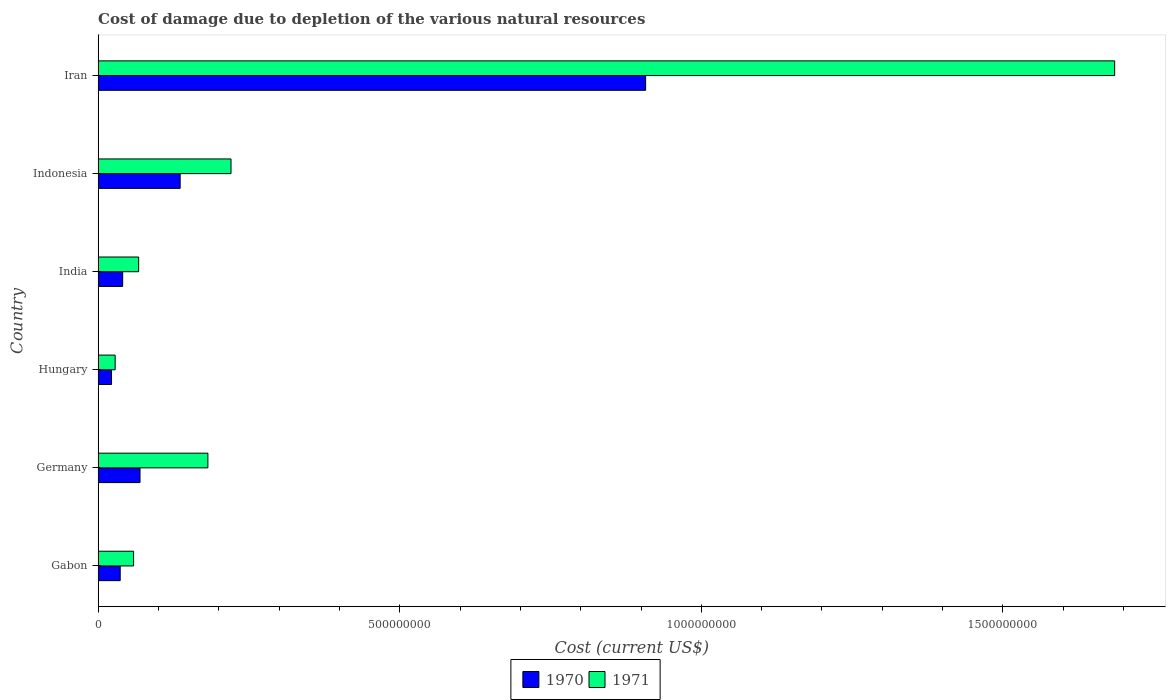Are the number of bars per tick equal to the number of legend labels?
Offer a terse response. Yes. Are the number of bars on each tick of the Y-axis equal?
Your response must be concise. Yes. How many bars are there on the 1st tick from the bottom?
Offer a very short reply. 2. In how many cases, is the number of bars for a given country not equal to the number of legend labels?
Your answer should be very brief. 0. What is the cost of damage caused due to the depletion of various natural resources in 1970 in Germany?
Your answer should be compact. 6.95e+07. Across all countries, what is the maximum cost of damage caused due to the depletion of various natural resources in 1970?
Keep it short and to the point. 9.08e+08. Across all countries, what is the minimum cost of damage caused due to the depletion of various natural resources in 1970?
Your answer should be compact. 2.22e+07. In which country was the cost of damage caused due to the depletion of various natural resources in 1971 maximum?
Your answer should be compact. Iran. In which country was the cost of damage caused due to the depletion of various natural resources in 1970 minimum?
Your answer should be compact. Hungary. What is the total cost of damage caused due to the depletion of various natural resources in 1970 in the graph?
Your response must be concise. 1.21e+09. What is the difference between the cost of damage caused due to the depletion of various natural resources in 1971 in Gabon and that in Iran?
Make the answer very short. -1.63e+09. What is the difference between the cost of damage caused due to the depletion of various natural resources in 1970 in Iran and the cost of damage caused due to the depletion of various natural resources in 1971 in Hungary?
Give a very brief answer. 8.79e+08. What is the average cost of damage caused due to the depletion of various natural resources in 1970 per country?
Ensure brevity in your answer.  2.02e+08. What is the difference between the cost of damage caused due to the depletion of various natural resources in 1970 and cost of damage caused due to the depletion of various natural resources in 1971 in Iran?
Ensure brevity in your answer.  -7.78e+08. In how many countries, is the cost of damage caused due to the depletion of various natural resources in 1970 greater than 100000000 US$?
Your answer should be compact. 2. What is the ratio of the cost of damage caused due to the depletion of various natural resources in 1971 in Hungary to that in India?
Your response must be concise. 0.42. Is the difference between the cost of damage caused due to the depletion of various natural resources in 1970 in Gabon and Indonesia greater than the difference between the cost of damage caused due to the depletion of various natural resources in 1971 in Gabon and Indonesia?
Your answer should be compact. Yes. What is the difference between the highest and the second highest cost of damage caused due to the depletion of various natural resources in 1970?
Provide a succinct answer. 7.72e+08. What is the difference between the highest and the lowest cost of damage caused due to the depletion of various natural resources in 1971?
Offer a terse response. 1.66e+09. In how many countries, is the cost of damage caused due to the depletion of various natural resources in 1970 greater than the average cost of damage caused due to the depletion of various natural resources in 1970 taken over all countries?
Your answer should be very brief. 1. Is the sum of the cost of damage caused due to the depletion of various natural resources in 1970 in Germany and Hungary greater than the maximum cost of damage caused due to the depletion of various natural resources in 1971 across all countries?
Keep it short and to the point. No. How many countries are there in the graph?
Ensure brevity in your answer.  6. Does the graph contain any zero values?
Ensure brevity in your answer.  No. Where does the legend appear in the graph?
Give a very brief answer. Bottom center. How many legend labels are there?
Provide a succinct answer. 2. How are the legend labels stacked?
Offer a terse response. Horizontal. What is the title of the graph?
Make the answer very short. Cost of damage due to depletion of the various natural resources. Does "2001" appear as one of the legend labels in the graph?
Offer a very short reply. No. What is the label or title of the X-axis?
Offer a terse response. Cost (current US$). What is the Cost (current US$) in 1970 in Gabon?
Give a very brief answer. 3.66e+07. What is the Cost (current US$) in 1971 in Gabon?
Your answer should be very brief. 5.88e+07. What is the Cost (current US$) of 1970 in Germany?
Offer a terse response. 6.95e+07. What is the Cost (current US$) of 1971 in Germany?
Keep it short and to the point. 1.82e+08. What is the Cost (current US$) of 1970 in Hungary?
Offer a very short reply. 2.22e+07. What is the Cost (current US$) of 1971 in Hungary?
Keep it short and to the point. 2.83e+07. What is the Cost (current US$) in 1970 in India?
Offer a very short reply. 4.07e+07. What is the Cost (current US$) in 1971 in India?
Offer a terse response. 6.72e+07. What is the Cost (current US$) of 1970 in Indonesia?
Your answer should be very brief. 1.36e+08. What is the Cost (current US$) in 1971 in Indonesia?
Your answer should be compact. 2.20e+08. What is the Cost (current US$) of 1970 in Iran?
Give a very brief answer. 9.08e+08. What is the Cost (current US$) in 1971 in Iran?
Keep it short and to the point. 1.69e+09. Across all countries, what is the maximum Cost (current US$) in 1970?
Provide a succinct answer. 9.08e+08. Across all countries, what is the maximum Cost (current US$) in 1971?
Provide a short and direct response. 1.69e+09. Across all countries, what is the minimum Cost (current US$) in 1970?
Offer a terse response. 2.22e+07. Across all countries, what is the minimum Cost (current US$) in 1971?
Your answer should be very brief. 2.83e+07. What is the total Cost (current US$) of 1970 in the graph?
Your response must be concise. 1.21e+09. What is the total Cost (current US$) in 1971 in the graph?
Provide a succinct answer. 2.24e+09. What is the difference between the Cost (current US$) in 1970 in Gabon and that in Germany?
Make the answer very short. -3.29e+07. What is the difference between the Cost (current US$) in 1971 in Gabon and that in Germany?
Your answer should be compact. -1.23e+08. What is the difference between the Cost (current US$) in 1970 in Gabon and that in Hungary?
Offer a very short reply. 1.44e+07. What is the difference between the Cost (current US$) in 1971 in Gabon and that in Hungary?
Offer a very short reply. 3.05e+07. What is the difference between the Cost (current US$) in 1970 in Gabon and that in India?
Offer a terse response. -4.09e+06. What is the difference between the Cost (current US$) in 1971 in Gabon and that in India?
Ensure brevity in your answer.  -8.41e+06. What is the difference between the Cost (current US$) in 1970 in Gabon and that in Indonesia?
Your answer should be very brief. -9.94e+07. What is the difference between the Cost (current US$) in 1971 in Gabon and that in Indonesia?
Your answer should be compact. -1.62e+08. What is the difference between the Cost (current US$) of 1970 in Gabon and that in Iran?
Offer a terse response. -8.71e+08. What is the difference between the Cost (current US$) of 1971 in Gabon and that in Iran?
Give a very brief answer. -1.63e+09. What is the difference between the Cost (current US$) of 1970 in Germany and that in Hungary?
Provide a succinct answer. 4.72e+07. What is the difference between the Cost (current US$) of 1971 in Germany and that in Hungary?
Provide a succinct answer. 1.54e+08. What is the difference between the Cost (current US$) of 1970 in Germany and that in India?
Ensure brevity in your answer.  2.88e+07. What is the difference between the Cost (current US$) of 1971 in Germany and that in India?
Offer a terse response. 1.15e+08. What is the difference between the Cost (current US$) of 1970 in Germany and that in Indonesia?
Ensure brevity in your answer.  -6.65e+07. What is the difference between the Cost (current US$) of 1971 in Germany and that in Indonesia?
Your answer should be compact. -3.83e+07. What is the difference between the Cost (current US$) in 1970 in Germany and that in Iran?
Your answer should be compact. -8.38e+08. What is the difference between the Cost (current US$) of 1971 in Germany and that in Iran?
Make the answer very short. -1.50e+09. What is the difference between the Cost (current US$) of 1970 in Hungary and that in India?
Your response must be concise. -1.85e+07. What is the difference between the Cost (current US$) in 1971 in Hungary and that in India?
Ensure brevity in your answer.  -3.89e+07. What is the difference between the Cost (current US$) of 1970 in Hungary and that in Indonesia?
Your answer should be compact. -1.14e+08. What is the difference between the Cost (current US$) in 1971 in Hungary and that in Indonesia?
Your response must be concise. -1.92e+08. What is the difference between the Cost (current US$) in 1970 in Hungary and that in Iran?
Keep it short and to the point. -8.85e+08. What is the difference between the Cost (current US$) in 1971 in Hungary and that in Iran?
Your answer should be very brief. -1.66e+09. What is the difference between the Cost (current US$) in 1970 in India and that in Indonesia?
Your answer should be compact. -9.53e+07. What is the difference between the Cost (current US$) in 1971 in India and that in Indonesia?
Make the answer very short. -1.53e+08. What is the difference between the Cost (current US$) in 1970 in India and that in Iran?
Make the answer very short. -8.67e+08. What is the difference between the Cost (current US$) of 1971 in India and that in Iran?
Your answer should be compact. -1.62e+09. What is the difference between the Cost (current US$) of 1970 in Indonesia and that in Iran?
Your response must be concise. -7.72e+08. What is the difference between the Cost (current US$) of 1971 in Indonesia and that in Iran?
Your response must be concise. -1.46e+09. What is the difference between the Cost (current US$) in 1970 in Gabon and the Cost (current US$) in 1971 in Germany?
Provide a short and direct response. -1.45e+08. What is the difference between the Cost (current US$) in 1970 in Gabon and the Cost (current US$) in 1971 in Hungary?
Your response must be concise. 8.35e+06. What is the difference between the Cost (current US$) in 1970 in Gabon and the Cost (current US$) in 1971 in India?
Give a very brief answer. -3.06e+07. What is the difference between the Cost (current US$) of 1970 in Gabon and the Cost (current US$) of 1971 in Indonesia?
Make the answer very short. -1.84e+08. What is the difference between the Cost (current US$) of 1970 in Gabon and the Cost (current US$) of 1971 in Iran?
Make the answer very short. -1.65e+09. What is the difference between the Cost (current US$) of 1970 in Germany and the Cost (current US$) of 1971 in Hungary?
Provide a short and direct response. 4.12e+07. What is the difference between the Cost (current US$) of 1970 in Germany and the Cost (current US$) of 1971 in India?
Give a very brief answer. 2.27e+06. What is the difference between the Cost (current US$) of 1970 in Germany and the Cost (current US$) of 1971 in Indonesia?
Provide a succinct answer. -1.51e+08. What is the difference between the Cost (current US$) in 1970 in Germany and the Cost (current US$) in 1971 in Iran?
Ensure brevity in your answer.  -1.62e+09. What is the difference between the Cost (current US$) of 1970 in Hungary and the Cost (current US$) of 1971 in India?
Provide a short and direct response. -4.50e+07. What is the difference between the Cost (current US$) in 1970 in Hungary and the Cost (current US$) in 1971 in Indonesia?
Offer a terse response. -1.98e+08. What is the difference between the Cost (current US$) in 1970 in Hungary and the Cost (current US$) in 1971 in Iran?
Keep it short and to the point. -1.66e+09. What is the difference between the Cost (current US$) in 1970 in India and the Cost (current US$) in 1971 in Indonesia?
Make the answer very short. -1.80e+08. What is the difference between the Cost (current US$) in 1970 in India and the Cost (current US$) in 1971 in Iran?
Your answer should be compact. -1.64e+09. What is the difference between the Cost (current US$) of 1970 in Indonesia and the Cost (current US$) of 1971 in Iran?
Your answer should be compact. -1.55e+09. What is the average Cost (current US$) in 1970 per country?
Offer a terse response. 2.02e+08. What is the average Cost (current US$) in 1971 per country?
Your answer should be very brief. 3.74e+08. What is the difference between the Cost (current US$) in 1970 and Cost (current US$) in 1971 in Gabon?
Ensure brevity in your answer.  -2.22e+07. What is the difference between the Cost (current US$) in 1970 and Cost (current US$) in 1971 in Germany?
Give a very brief answer. -1.13e+08. What is the difference between the Cost (current US$) of 1970 and Cost (current US$) of 1971 in Hungary?
Provide a short and direct response. -6.02e+06. What is the difference between the Cost (current US$) of 1970 and Cost (current US$) of 1971 in India?
Make the answer very short. -2.65e+07. What is the difference between the Cost (current US$) in 1970 and Cost (current US$) in 1971 in Indonesia?
Provide a succinct answer. -8.43e+07. What is the difference between the Cost (current US$) in 1970 and Cost (current US$) in 1971 in Iran?
Offer a very short reply. -7.78e+08. What is the ratio of the Cost (current US$) in 1970 in Gabon to that in Germany?
Your answer should be compact. 0.53. What is the ratio of the Cost (current US$) of 1971 in Gabon to that in Germany?
Ensure brevity in your answer.  0.32. What is the ratio of the Cost (current US$) of 1970 in Gabon to that in Hungary?
Your answer should be compact. 1.65. What is the ratio of the Cost (current US$) in 1971 in Gabon to that in Hungary?
Offer a very short reply. 2.08. What is the ratio of the Cost (current US$) in 1970 in Gabon to that in India?
Give a very brief answer. 0.9. What is the ratio of the Cost (current US$) in 1971 in Gabon to that in India?
Offer a terse response. 0.87. What is the ratio of the Cost (current US$) in 1970 in Gabon to that in Indonesia?
Offer a very short reply. 0.27. What is the ratio of the Cost (current US$) in 1971 in Gabon to that in Indonesia?
Offer a terse response. 0.27. What is the ratio of the Cost (current US$) of 1970 in Gabon to that in Iran?
Your response must be concise. 0.04. What is the ratio of the Cost (current US$) of 1971 in Gabon to that in Iran?
Your answer should be compact. 0.03. What is the ratio of the Cost (current US$) of 1970 in Germany to that in Hungary?
Ensure brevity in your answer.  3.12. What is the ratio of the Cost (current US$) in 1971 in Germany to that in Hungary?
Offer a terse response. 6.44. What is the ratio of the Cost (current US$) in 1970 in Germany to that in India?
Your response must be concise. 1.71. What is the ratio of the Cost (current US$) in 1971 in Germany to that in India?
Your response must be concise. 2.71. What is the ratio of the Cost (current US$) in 1970 in Germany to that in Indonesia?
Ensure brevity in your answer.  0.51. What is the ratio of the Cost (current US$) in 1971 in Germany to that in Indonesia?
Your response must be concise. 0.83. What is the ratio of the Cost (current US$) in 1970 in Germany to that in Iran?
Ensure brevity in your answer.  0.08. What is the ratio of the Cost (current US$) of 1971 in Germany to that in Iran?
Offer a very short reply. 0.11. What is the ratio of the Cost (current US$) in 1970 in Hungary to that in India?
Your answer should be very brief. 0.55. What is the ratio of the Cost (current US$) in 1971 in Hungary to that in India?
Your answer should be very brief. 0.42. What is the ratio of the Cost (current US$) in 1970 in Hungary to that in Indonesia?
Your response must be concise. 0.16. What is the ratio of the Cost (current US$) of 1971 in Hungary to that in Indonesia?
Keep it short and to the point. 0.13. What is the ratio of the Cost (current US$) in 1970 in Hungary to that in Iran?
Make the answer very short. 0.02. What is the ratio of the Cost (current US$) in 1971 in Hungary to that in Iran?
Ensure brevity in your answer.  0.02. What is the ratio of the Cost (current US$) of 1970 in India to that in Indonesia?
Provide a succinct answer. 0.3. What is the ratio of the Cost (current US$) of 1971 in India to that in Indonesia?
Provide a succinct answer. 0.3. What is the ratio of the Cost (current US$) of 1970 in India to that in Iran?
Offer a very short reply. 0.04. What is the ratio of the Cost (current US$) of 1971 in India to that in Iran?
Your response must be concise. 0.04. What is the ratio of the Cost (current US$) in 1970 in Indonesia to that in Iran?
Your response must be concise. 0.15. What is the ratio of the Cost (current US$) of 1971 in Indonesia to that in Iran?
Make the answer very short. 0.13. What is the difference between the highest and the second highest Cost (current US$) of 1970?
Provide a short and direct response. 7.72e+08. What is the difference between the highest and the second highest Cost (current US$) of 1971?
Offer a terse response. 1.46e+09. What is the difference between the highest and the lowest Cost (current US$) of 1970?
Your answer should be very brief. 8.85e+08. What is the difference between the highest and the lowest Cost (current US$) in 1971?
Your response must be concise. 1.66e+09. 